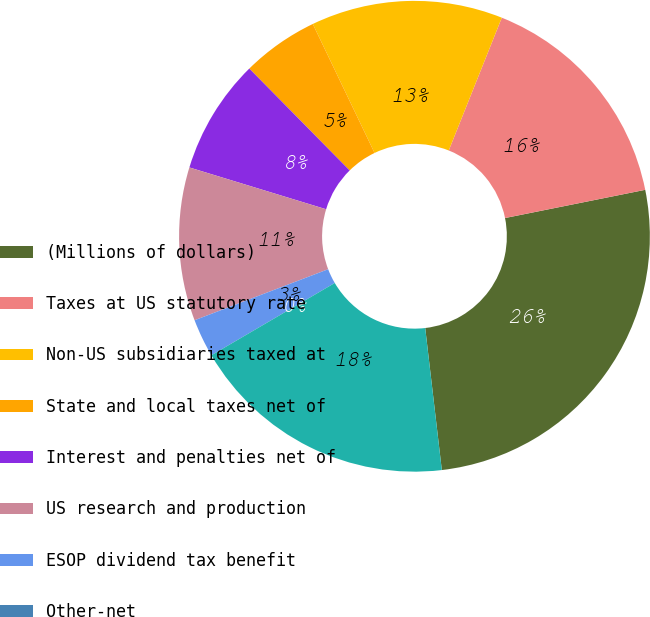<chart> <loc_0><loc_0><loc_500><loc_500><pie_chart><fcel>(Millions of dollars)<fcel>Taxes at US statutory rate<fcel>Non-US subsidiaries taxed at<fcel>State and local taxes net of<fcel>Interest and penalties net of<fcel>US research and production<fcel>ESOP dividend tax benefit<fcel>Other-net<fcel>Provision (benefit) for income<nl><fcel>26.31%<fcel>15.79%<fcel>13.16%<fcel>5.27%<fcel>7.9%<fcel>10.53%<fcel>2.63%<fcel>0.0%<fcel>18.42%<nl></chart> 